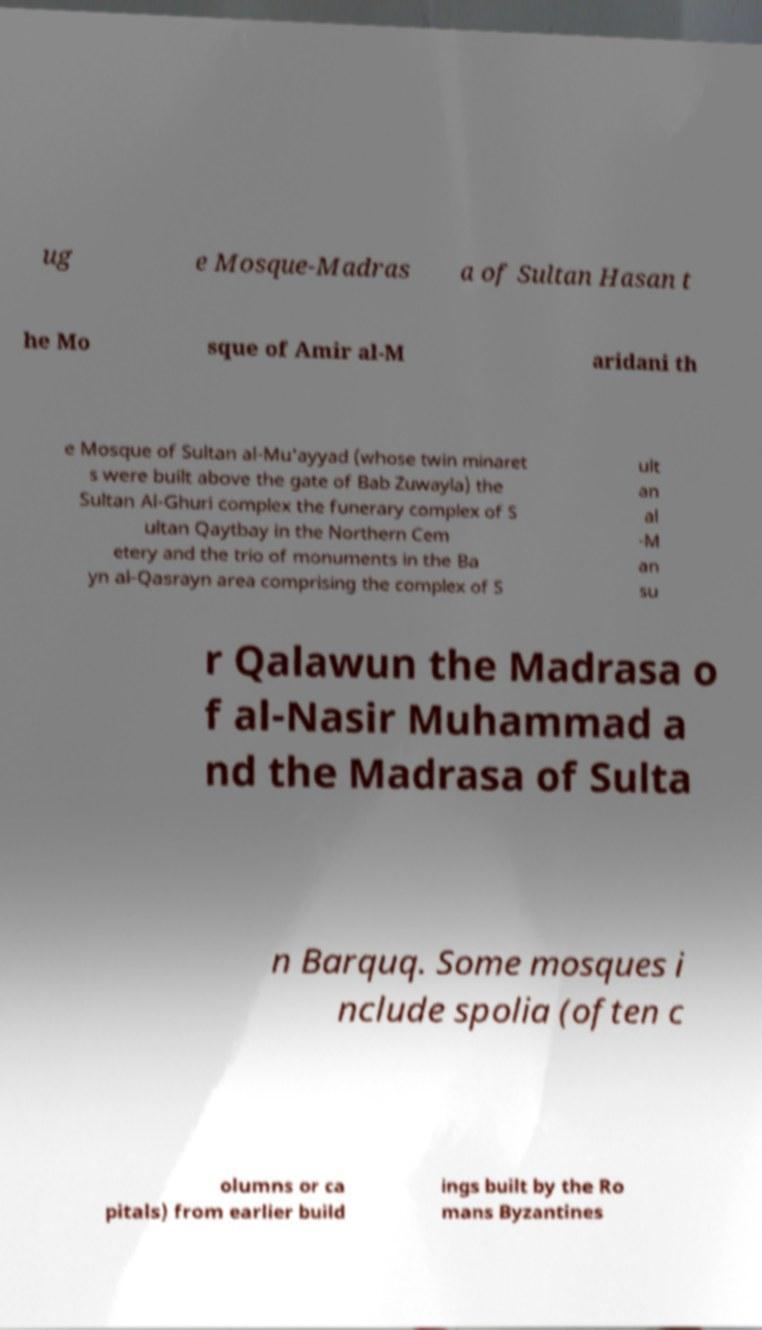Can you read and provide the text displayed in the image?This photo seems to have some interesting text. Can you extract and type it out for me? ug e Mosque-Madras a of Sultan Hasan t he Mo sque of Amir al-M aridani th e Mosque of Sultan al-Mu'ayyad (whose twin minaret s were built above the gate of Bab Zuwayla) the Sultan Al-Ghuri complex the funerary complex of S ultan Qaytbay in the Northern Cem etery and the trio of monuments in the Ba yn al-Qasrayn area comprising the complex of S ult an al -M an su r Qalawun the Madrasa o f al-Nasir Muhammad a nd the Madrasa of Sulta n Barquq. Some mosques i nclude spolia (often c olumns or ca pitals) from earlier build ings built by the Ro mans Byzantines 